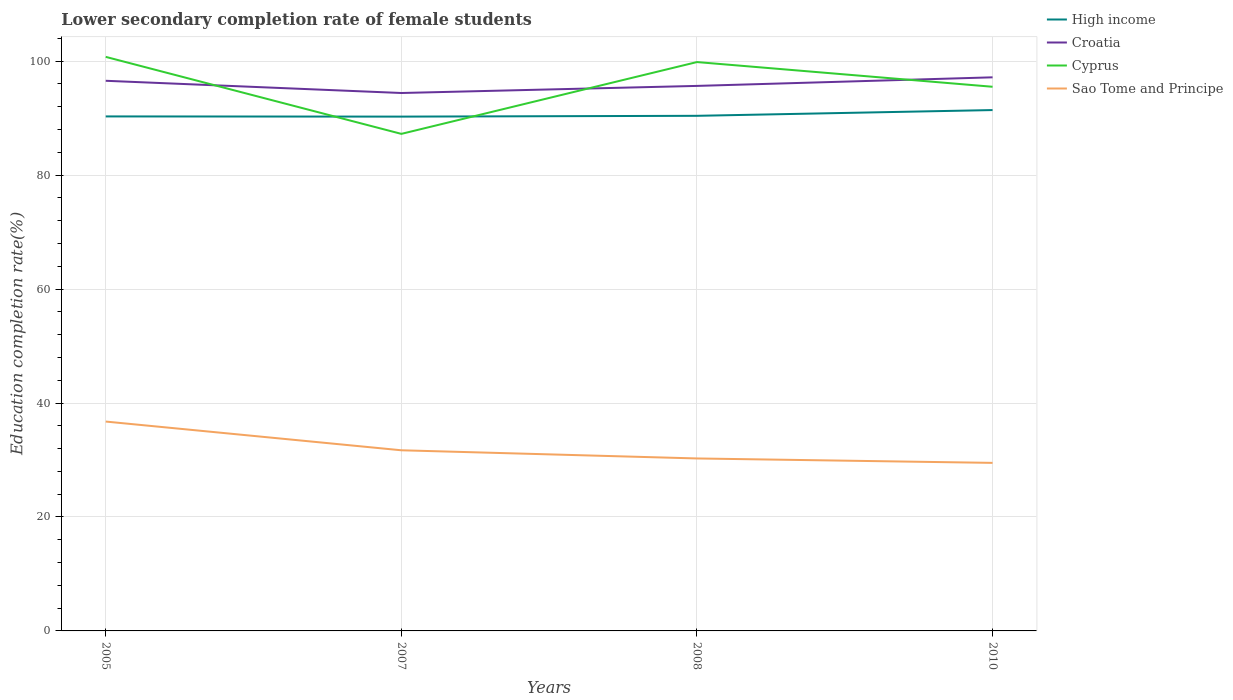Across all years, what is the maximum lower secondary completion rate of female students in High income?
Make the answer very short. 90.26. In which year was the lower secondary completion rate of female students in Cyprus maximum?
Your answer should be compact. 2007. What is the total lower secondary completion rate of female students in High income in the graph?
Keep it short and to the point. -0.14. What is the difference between the highest and the second highest lower secondary completion rate of female students in Cyprus?
Ensure brevity in your answer.  13.51. Is the lower secondary completion rate of female students in Cyprus strictly greater than the lower secondary completion rate of female students in Sao Tome and Principe over the years?
Your answer should be very brief. No. How many lines are there?
Your answer should be compact. 4. What is the difference between two consecutive major ticks on the Y-axis?
Offer a very short reply. 20. Does the graph contain any zero values?
Offer a very short reply. No. Does the graph contain grids?
Your answer should be very brief. Yes. Where does the legend appear in the graph?
Ensure brevity in your answer.  Top right. How many legend labels are there?
Ensure brevity in your answer.  4. How are the legend labels stacked?
Make the answer very short. Vertical. What is the title of the graph?
Provide a short and direct response. Lower secondary completion rate of female students. Does "Pacific island small states" appear as one of the legend labels in the graph?
Your response must be concise. No. What is the label or title of the Y-axis?
Offer a terse response. Education completion rate(%). What is the Education completion rate(%) in High income in 2005?
Your answer should be compact. 90.3. What is the Education completion rate(%) of Croatia in 2005?
Offer a very short reply. 96.55. What is the Education completion rate(%) in Cyprus in 2005?
Offer a very short reply. 100.75. What is the Education completion rate(%) of Sao Tome and Principe in 2005?
Provide a short and direct response. 36.74. What is the Education completion rate(%) in High income in 2007?
Your answer should be compact. 90.26. What is the Education completion rate(%) of Croatia in 2007?
Provide a succinct answer. 94.41. What is the Education completion rate(%) of Cyprus in 2007?
Provide a succinct answer. 87.23. What is the Education completion rate(%) in Sao Tome and Principe in 2007?
Make the answer very short. 31.7. What is the Education completion rate(%) in High income in 2008?
Your answer should be compact. 90.4. What is the Education completion rate(%) of Croatia in 2008?
Ensure brevity in your answer.  95.65. What is the Education completion rate(%) of Cyprus in 2008?
Offer a terse response. 99.83. What is the Education completion rate(%) in Sao Tome and Principe in 2008?
Make the answer very short. 30.27. What is the Education completion rate(%) in High income in 2010?
Provide a succinct answer. 91.41. What is the Education completion rate(%) of Croatia in 2010?
Offer a very short reply. 97.16. What is the Education completion rate(%) of Cyprus in 2010?
Offer a terse response. 95.5. What is the Education completion rate(%) of Sao Tome and Principe in 2010?
Provide a succinct answer. 29.49. Across all years, what is the maximum Education completion rate(%) of High income?
Offer a very short reply. 91.41. Across all years, what is the maximum Education completion rate(%) in Croatia?
Your response must be concise. 97.16. Across all years, what is the maximum Education completion rate(%) in Cyprus?
Your response must be concise. 100.75. Across all years, what is the maximum Education completion rate(%) in Sao Tome and Principe?
Give a very brief answer. 36.74. Across all years, what is the minimum Education completion rate(%) of High income?
Your answer should be compact. 90.26. Across all years, what is the minimum Education completion rate(%) of Croatia?
Provide a short and direct response. 94.41. Across all years, what is the minimum Education completion rate(%) in Cyprus?
Provide a succinct answer. 87.23. Across all years, what is the minimum Education completion rate(%) of Sao Tome and Principe?
Provide a short and direct response. 29.49. What is the total Education completion rate(%) in High income in the graph?
Your response must be concise. 362.37. What is the total Education completion rate(%) of Croatia in the graph?
Ensure brevity in your answer.  383.76. What is the total Education completion rate(%) in Cyprus in the graph?
Keep it short and to the point. 383.31. What is the total Education completion rate(%) of Sao Tome and Principe in the graph?
Your response must be concise. 128.21. What is the difference between the Education completion rate(%) in High income in 2005 and that in 2007?
Provide a succinct answer. 0.03. What is the difference between the Education completion rate(%) in Croatia in 2005 and that in 2007?
Your answer should be compact. 2.14. What is the difference between the Education completion rate(%) of Cyprus in 2005 and that in 2007?
Make the answer very short. 13.51. What is the difference between the Education completion rate(%) of Sao Tome and Principe in 2005 and that in 2007?
Your answer should be very brief. 5.04. What is the difference between the Education completion rate(%) in High income in 2005 and that in 2008?
Offer a terse response. -0.11. What is the difference between the Education completion rate(%) in Croatia in 2005 and that in 2008?
Ensure brevity in your answer.  0.9. What is the difference between the Education completion rate(%) of Cyprus in 2005 and that in 2008?
Your answer should be very brief. 0.91. What is the difference between the Education completion rate(%) of Sao Tome and Principe in 2005 and that in 2008?
Your answer should be compact. 6.47. What is the difference between the Education completion rate(%) in High income in 2005 and that in 2010?
Provide a short and direct response. -1.11. What is the difference between the Education completion rate(%) in Croatia in 2005 and that in 2010?
Provide a short and direct response. -0.61. What is the difference between the Education completion rate(%) of Cyprus in 2005 and that in 2010?
Keep it short and to the point. 5.25. What is the difference between the Education completion rate(%) in Sao Tome and Principe in 2005 and that in 2010?
Keep it short and to the point. 7.25. What is the difference between the Education completion rate(%) of High income in 2007 and that in 2008?
Offer a terse response. -0.14. What is the difference between the Education completion rate(%) of Croatia in 2007 and that in 2008?
Ensure brevity in your answer.  -1.24. What is the difference between the Education completion rate(%) in Cyprus in 2007 and that in 2008?
Offer a terse response. -12.6. What is the difference between the Education completion rate(%) of Sao Tome and Principe in 2007 and that in 2008?
Offer a very short reply. 1.43. What is the difference between the Education completion rate(%) of High income in 2007 and that in 2010?
Provide a short and direct response. -1.15. What is the difference between the Education completion rate(%) of Croatia in 2007 and that in 2010?
Provide a short and direct response. -2.75. What is the difference between the Education completion rate(%) of Cyprus in 2007 and that in 2010?
Provide a succinct answer. -8.27. What is the difference between the Education completion rate(%) in Sao Tome and Principe in 2007 and that in 2010?
Your response must be concise. 2.21. What is the difference between the Education completion rate(%) of High income in 2008 and that in 2010?
Give a very brief answer. -1.01. What is the difference between the Education completion rate(%) of Croatia in 2008 and that in 2010?
Keep it short and to the point. -1.51. What is the difference between the Education completion rate(%) in Cyprus in 2008 and that in 2010?
Your response must be concise. 4.34. What is the difference between the Education completion rate(%) of Sao Tome and Principe in 2008 and that in 2010?
Make the answer very short. 0.78. What is the difference between the Education completion rate(%) of High income in 2005 and the Education completion rate(%) of Croatia in 2007?
Offer a very short reply. -4.11. What is the difference between the Education completion rate(%) of High income in 2005 and the Education completion rate(%) of Cyprus in 2007?
Your answer should be compact. 3.06. What is the difference between the Education completion rate(%) in High income in 2005 and the Education completion rate(%) in Sao Tome and Principe in 2007?
Ensure brevity in your answer.  58.59. What is the difference between the Education completion rate(%) of Croatia in 2005 and the Education completion rate(%) of Cyprus in 2007?
Give a very brief answer. 9.32. What is the difference between the Education completion rate(%) of Croatia in 2005 and the Education completion rate(%) of Sao Tome and Principe in 2007?
Offer a terse response. 64.85. What is the difference between the Education completion rate(%) in Cyprus in 2005 and the Education completion rate(%) in Sao Tome and Principe in 2007?
Ensure brevity in your answer.  69.04. What is the difference between the Education completion rate(%) of High income in 2005 and the Education completion rate(%) of Croatia in 2008?
Provide a succinct answer. -5.35. What is the difference between the Education completion rate(%) in High income in 2005 and the Education completion rate(%) in Cyprus in 2008?
Make the answer very short. -9.54. What is the difference between the Education completion rate(%) of High income in 2005 and the Education completion rate(%) of Sao Tome and Principe in 2008?
Offer a terse response. 60.03. What is the difference between the Education completion rate(%) in Croatia in 2005 and the Education completion rate(%) in Cyprus in 2008?
Give a very brief answer. -3.28. What is the difference between the Education completion rate(%) of Croatia in 2005 and the Education completion rate(%) of Sao Tome and Principe in 2008?
Make the answer very short. 66.28. What is the difference between the Education completion rate(%) in Cyprus in 2005 and the Education completion rate(%) in Sao Tome and Principe in 2008?
Your answer should be very brief. 70.48. What is the difference between the Education completion rate(%) in High income in 2005 and the Education completion rate(%) in Croatia in 2010?
Ensure brevity in your answer.  -6.86. What is the difference between the Education completion rate(%) of High income in 2005 and the Education completion rate(%) of Cyprus in 2010?
Keep it short and to the point. -5.2. What is the difference between the Education completion rate(%) in High income in 2005 and the Education completion rate(%) in Sao Tome and Principe in 2010?
Offer a very short reply. 60.8. What is the difference between the Education completion rate(%) of Croatia in 2005 and the Education completion rate(%) of Cyprus in 2010?
Give a very brief answer. 1.05. What is the difference between the Education completion rate(%) in Croatia in 2005 and the Education completion rate(%) in Sao Tome and Principe in 2010?
Provide a short and direct response. 67.06. What is the difference between the Education completion rate(%) in Cyprus in 2005 and the Education completion rate(%) in Sao Tome and Principe in 2010?
Give a very brief answer. 71.25. What is the difference between the Education completion rate(%) in High income in 2007 and the Education completion rate(%) in Croatia in 2008?
Your answer should be very brief. -5.39. What is the difference between the Education completion rate(%) in High income in 2007 and the Education completion rate(%) in Cyprus in 2008?
Ensure brevity in your answer.  -9.57. What is the difference between the Education completion rate(%) of High income in 2007 and the Education completion rate(%) of Sao Tome and Principe in 2008?
Offer a terse response. 59.99. What is the difference between the Education completion rate(%) in Croatia in 2007 and the Education completion rate(%) in Cyprus in 2008?
Make the answer very short. -5.43. What is the difference between the Education completion rate(%) of Croatia in 2007 and the Education completion rate(%) of Sao Tome and Principe in 2008?
Offer a terse response. 64.14. What is the difference between the Education completion rate(%) in Cyprus in 2007 and the Education completion rate(%) in Sao Tome and Principe in 2008?
Keep it short and to the point. 56.96. What is the difference between the Education completion rate(%) in High income in 2007 and the Education completion rate(%) in Croatia in 2010?
Offer a very short reply. -6.9. What is the difference between the Education completion rate(%) of High income in 2007 and the Education completion rate(%) of Cyprus in 2010?
Offer a very short reply. -5.24. What is the difference between the Education completion rate(%) in High income in 2007 and the Education completion rate(%) in Sao Tome and Principe in 2010?
Your answer should be compact. 60.77. What is the difference between the Education completion rate(%) of Croatia in 2007 and the Education completion rate(%) of Cyprus in 2010?
Offer a very short reply. -1.09. What is the difference between the Education completion rate(%) in Croatia in 2007 and the Education completion rate(%) in Sao Tome and Principe in 2010?
Give a very brief answer. 64.91. What is the difference between the Education completion rate(%) in Cyprus in 2007 and the Education completion rate(%) in Sao Tome and Principe in 2010?
Provide a succinct answer. 57.74. What is the difference between the Education completion rate(%) of High income in 2008 and the Education completion rate(%) of Croatia in 2010?
Provide a succinct answer. -6.75. What is the difference between the Education completion rate(%) in High income in 2008 and the Education completion rate(%) in Cyprus in 2010?
Offer a terse response. -5.1. What is the difference between the Education completion rate(%) in High income in 2008 and the Education completion rate(%) in Sao Tome and Principe in 2010?
Your response must be concise. 60.91. What is the difference between the Education completion rate(%) in Croatia in 2008 and the Education completion rate(%) in Cyprus in 2010?
Keep it short and to the point. 0.15. What is the difference between the Education completion rate(%) of Croatia in 2008 and the Education completion rate(%) of Sao Tome and Principe in 2010?
Provide a short and direct response. 66.16. What is the difference between the Education completion rate(%) in Cyprus in 2008 and the Education completion rate(%) in Sao Tome and Principe in 2010?
Offer a terse response. 70.34. What is the average Education completion rate(%) of High income per year?
Provide a short and direct response. 90.59. What is the average Education completion rate(%) in Croatia per year?
Your answer should be very brief. 95.94. What is the average Education completion rate(%) in Cyprus per year?
Your answer should be very brief. 95.83. What is the average Education completion rate(%) in Sao Tome and Principe per year?
Keep it short and to the point. 32.05. In the year 2005, what is the difference between the Education completion rate(%) in High income and Education completion rate(%) in Croatia?
Give a very brief answer. -6.25. In the year 2005, what is the difference between the Education completion rate(%) of High income and Education completion rate(%) of Cyprus?
Offer a terse response. -10.45. In the year 2005, what is the difference between the Education completion rate(%) of High income and Education completion rate(%) of Sao Tome and Principe?
Offer a terse response. 53.55. In the year 2005, what is the difference between the Education completion rate(%) of Croatia and Education completion rate(%) of Cyprus?
Provide a short and direct response. -4.2. In the year 2005, what is the difference between the Education completion rate(%) in Croatia and Education completion rate(%) in Sao Tome and Principe?
Ensure brevity in your answer.  59.81. In the year 2005, what is the difference between the Education completion rate(%) of Cyprus and Education completion rate(%) of Sao Tome and Principe?
Your response must be concise. 64. In the year 2007, what is the difference between the Education completion rate(%) in High income and Education completion rate(%) in Croatia?
Offer a terse response. -4.14. In the year 2007, what is the difference between the Education completion rate(%) of High income and Education completion rate(%) of Cyprus?
Your answer should be compact. 3.03. In the year 2007, what is the difference between the Education completion rate(%) of High income and Education completion rate(%) of Sao Tome and Principe?
Your answer should be very brief. 58.56. In the year 2007, what is the difference between the Education completion rate(%) of Croatia and Education completion rate(%) of Cyprus?
Offer a terse response. 7.17. In the year 2007, what is the difference between the Education completion rate(%) in Croatia and Education completion rate(%) in Sao Tome and Principe?
Offer a very short reply. 62.7. In the year 2007, what is the difference between the Education completion rate(%) of Cyprus and Education completion rate(%) of Sao Tome and Principe?
Keep it short and to the point. 55.53. In the year 2008, what is the difference between the Education completion rate(%) of High income and Education completion rate(%) of Croatia?
Give a very brief answer. -5.25. In the year 2008, what is the difference between the Education completion rate(%) of High income and Education completion rate(%) of Cyprus?
Ensure brevity in your answer.  -9.43. In the year 2008, what is the difference between the Education completion rate(%) in High income and Education completion rate(%) in Sao Tome and Principe?
Provide a short and direct response. 60.13. In the year 2008, what is the difference between the Education completion rate(%) in Croatia and Education completion rate(%) in Cyprus?
Offer a very short reply. -4.18. In the year 2008, what is the difference between the Education completion rate(%) of Croatia and Education completion rate(%) of Sao Tome and Principe?
Ensure brevity in your answer.  65.38. In the year 2008, what is the difference between the Education completion rate(%) in Cyprus and Education completion rate(%) in Sao Tome and Principe?
Your answer should be very brief. 69.57. In the year 2010, what is the difference between the Education completion rate(%) of High income and Education completion rate(%) of Croatia?
Keep it short and to the point. -5.75. In the year 2010, what is the difference between the Education completion rate(%) in High income and Education completion rate(%) in Cyprus?
Your response must be concise. -4.09. In the year 2010, what is the difference between the Education completion rate(%) of High income and Education completion rate(%) of Sao Tome and Principe?
Give a very brief answer. 61.92. In the year 2010, what is the difference between the Education completion rate(%) in Croatia and Education completion rate(%) in Cyprus?
Give a very brief answer. 1.66. In the year 2010, what is the difference between the Education completion rate(%) in Croatia and Education completion rate(%) in Sao Tome and Principe?
Your response must be concise. 67.67. In the year 2010, what is the difference between the Education completion rate(%) of Cyprus and Education completion rate(%) of Sao Tome and Principe?
Offer a terse response. 66.01. What is the ratio of the Education completion rate(%) in High income in 2005 to that in 2007?
Make the answer very short. 1. What is the ratio of the Education completion rate(%) in Croatia in 2005 to that in 2007?
Ensure brevity in your answer.  1.02. What is the ratio of the Education completion rate(%) of Cyprus in 2005 to that in 2007?
Provide a succinct answer. 1.15. What is the ratio of the Education completion rate(%) in Sao Tome and Principe in 2005 to that in 2007?
Offer a terse response. 1.16. What is the ratio of the Education completion rate(%) of High income in 2005 to that in 2008?
Make the answer very short. 1. What is the ratio of the Education completion rate(%) in Croatia in 2005 to that in 2008?
Provide a succinct answer. 1.01. What is the ratio of the Education completion rate(%) of Cyprus in 2005 to that in 2008?
Your answer should be compact. 1.01. What is the ratio of the Education completion rate(%) in Sao Tome and Principe in 2005 to that in 2008?
Keep it short and to the point. 1.21. What is the ratio of the Education completion rate(%) in High income in 2005 to that in 2010?
Offer a terse response. 0.99. What is the ratio of the Education completion rate(%) of Croatia in 2005 to that in 2010?
Your answer should be very brief. 0.99. What is the ratio of the Education completion rate(%) of Cyprus in 2005 to that in 2010?
Ensure brevity in your answer.  1.05. What is the ratio of the Education completion rate(%) in Sao Tome and Principe in 2005 to that in 2010?
Your answer should be very brief. 1.25. What is the ratio of the Education completion rate(%) in High income in 2007 to that in 2008?
Give a very brief answer. 1. What is the ratio of the Education completion rate(%) in Cyprus in 2007 to that in 2008?
Your answer should be compact. 0.87. What is the ratio of the Education completion rate(%) in Sao Tome and Principe in 2007 to that in 2008?
Make the answer very short. 1.05. What is the ratio of the Education completion rate(%) of High income in 2007 to that in 2010?
Your answer should be compact. 0.99. What is the ratio of the Education completion rate(%) of Croatia in 2007 to that in 2010?
Provide a succinct answer. 0.97. What is the ratio of the Education completion rate(%) of Cyprus in 2007 to that in 2010?
Provide a succinct answer. 0.91. What is the ratio of the Education completion rate(%) of Sao Tome and Principe in 2007 to that in 2010?
Keep it short and to the point. 1.07. What is the ratio of the Education completion rate(%) in Croatia in 2008 to that in 2010?
Offer a terse response. 0.98. What is the ratio of the Education completion rate(%) in Cyprus in 2008 to that in 2010?
Provide a short and direct response. 1.05. What is the ratio of the Education completion rate(%) in Sao Tome and Principe in 2008 to that in 2010?
Your response must be concise. 1.03. What is the difference between the highest and the second highest Education completion rate(%) of Croatia?
Your answer should be very brief. 0.61. What is the difference between the highest and the second highest Education completion rate(%) of Cyprus?
Provide a short and direct response. 0.91. What is the difference between the highest and the second highest Education completion rate(%) in Sao Tome and Principe?
Your response must be concise. 5.04. What is the difference between the highest and the lowest Education completion rate(%) of High income?
Keep it short and to the point. 1.15. What is the difference between the highest and the lowest Education completion rate(%) in Croatia?
Make the answer very short. 2.75. What is the difference between the highest and the lowest Education completion rate(%) in Cyprus?
Offer a terse response. 13.51. What is the difference between the highest and the lowest Education completion rate(%) of Sao Tome and Principe?
Your answer should be very brief. 7.25. 